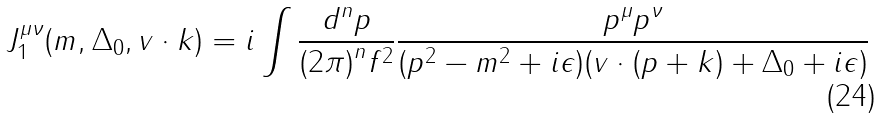<formula> <loc_0><loc_0><loc_500><loc_500>J ^ { \mu \nu } _ { 1 } ( m , \Delta _ { 0 } , v \cdot k ) = i \int \frac { d ^ { n } p } { { ( 2 \pi ) } ^ { n } f ^ { 2 } } \frac { p ^ { \mu } p ^ { \nu } } { ( p ^ { 2 } - m ^ { 2 } + i \epsilon ) ( v \cdot ( p + k ) + \Delta _ { 0 } + i \epsilon ) }</formula> 